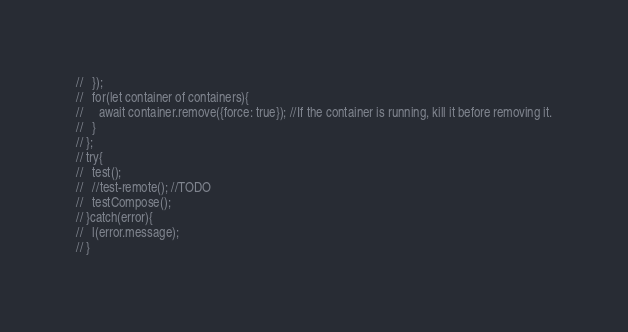Convert code to text. <code><loc_0><loc_0><loc_500><loc_500><_TypeScript_>//   });
//   for(let container of containers){
//     await container.remove({force: true}); //If the container is running, kill it before removing it.
//   }
// };
// try{
//   test();
//   //test-remote(); //TODO
//   testCompose();
// }catch(error){
//   l(error.message);
// }
</code> 